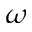Convert formula to latex. <formula><loc_0><loc_0><loc_500><loc_500>\omega</formula> 